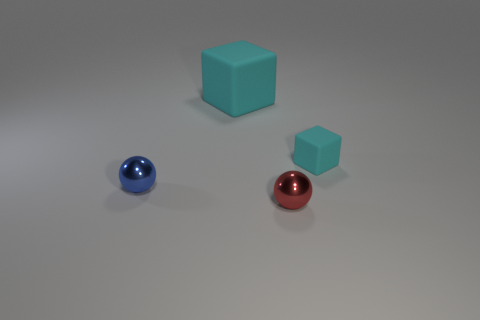Add 1 matte blocks. How many objects exist? 5 Subtract all big yellow matte cubes. Subtract all small cyan matte blocks. How many objects are left? 3 Add 4 cyan cubes. How many cyan cubes are left? 6 Add 4 large matte things. How many large matte things exist? 5 Subtract 0 gray balls. How many objects are left? 4 